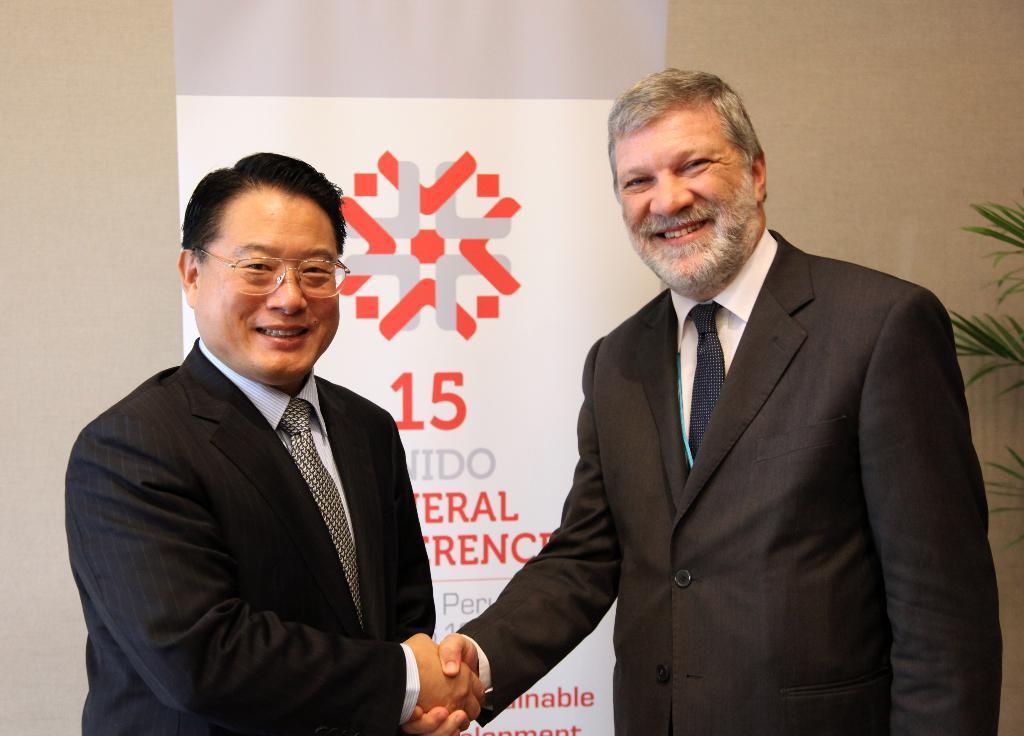In one or two sentences, can you explain what this image depicts? In this image there are two persons who are standing and smiling, and they are shaking hands with each other. In the background there is a board, on the board there is some text and a wall. On the right side there is a plant. 